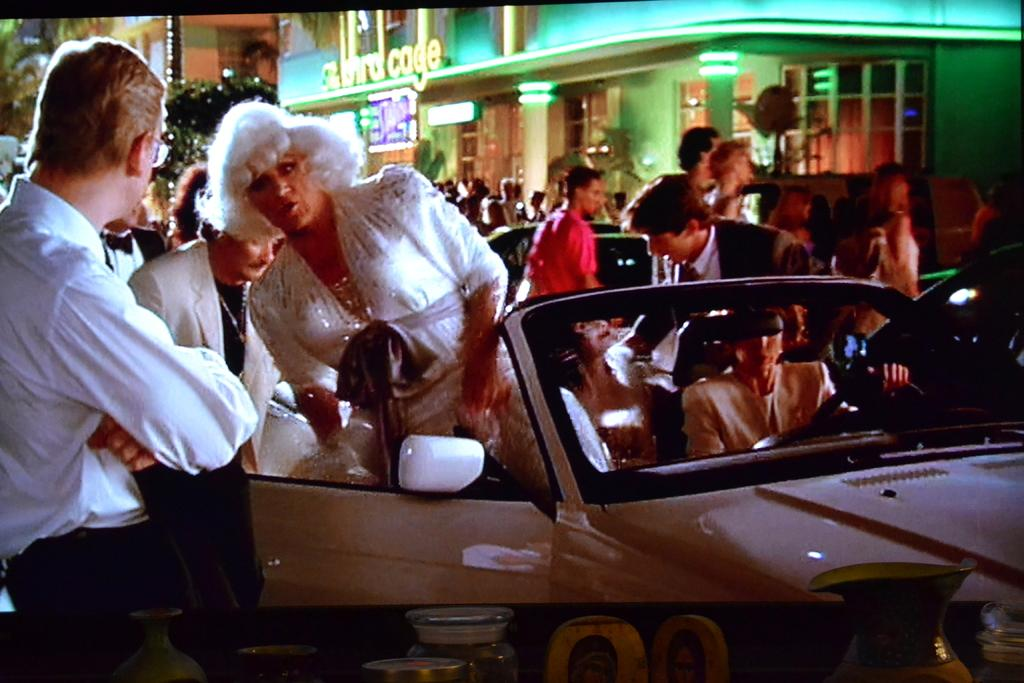How many people are in the image? There is a group of people in the image, but the exact number is not specified. What are the people in the image doing? Some people are standing, while others are sitting on cars. What can be seen in the background of the image? There is a building, pillars, light, trees, and a pole visible in the background of the image. What type of shoe is being used to learn how to play the steel guitar in the image? There is no shoe, learning, or steel guitar present in the image. 